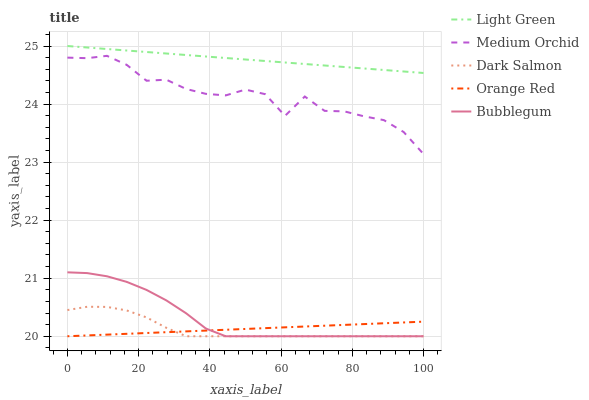Does Dark Salmon have the minimum area under the curve?
Answer yes or no. Yes. Does Light Green have the maximum area under the curve?
Answer yes or no. Yes. Does Medium Orchid have the minimum area under the curve?
Answer yes or no. No. Does Medium Orchid have the maximum area under the curve?
Answer yes or no. No. Is Orange Red the smoothest?
Answer yes or no. Yes. Is Medium Orchid the roughest?
Answer yes or no. Yes. Is Dark Salmon the smoothest?
Answer yes or no. No. Is Dark Salmon the roughest?
Answer yes or no. No. Does Bubblegum have the lowest value?
Answer yes or no. Yes. Does Medium Orchid have the lowest value?
Answer yes or no. No. Does Light Green have the highest value?
Answer yes or no. Yes. Does Medium Orchid have the highest value?
Answer yes or no. No. Is Bubblegum less than Medium Orchid?
Answer yes or no. Yes. Is Light Green greater than Dark Salmon?
Answer yes or no. Yes. Does Dark Salmon intersect Bubblegum?
Answer yes or no. Yes. Is Dark Salmon less than Bubblegum?
Answer yes or no. No. Is Dark Salmon greater than Bubblegum?
Answer yes or no. No. Does Bubblegum intersect Medium Orchid?
Answer yes or no. No. 